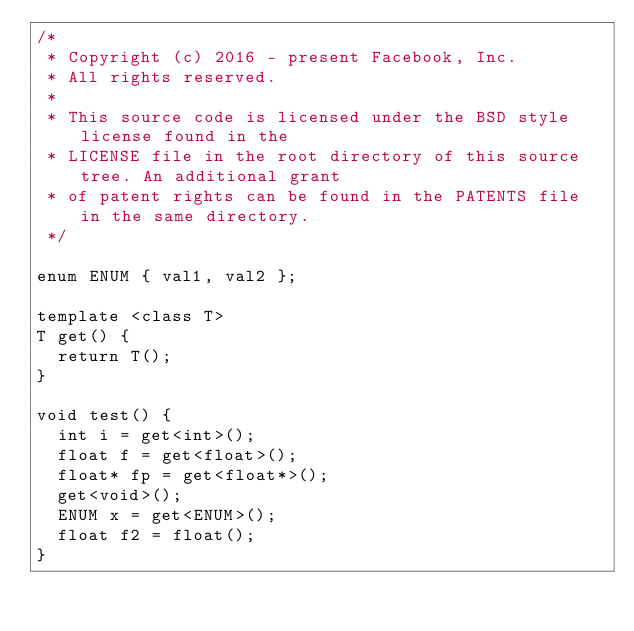<code> <loc_0><loc_0><loc_500><loc_500><_C++_>/*
 * Copyright (c) 2016 - present Facebook, Inc.
 * All rights reserved.
 *
 * This source code is licensed under the BSD style license found in the
 * LICENSE file in the root directory of this source tree. An additional grant
 * of patent rights can be found in the PATENTS file in the same directory.
 */

enum ENUM { val1, val2 };

template <class T>
T get() {
  return T();
}

void test() {
  int i = get<int>();
  float f = get<float>();
  float* fp = get<float*>();
  get<void>();
  ENUM x = get<ENUM>();
  float f2 = float();
}
</code> 